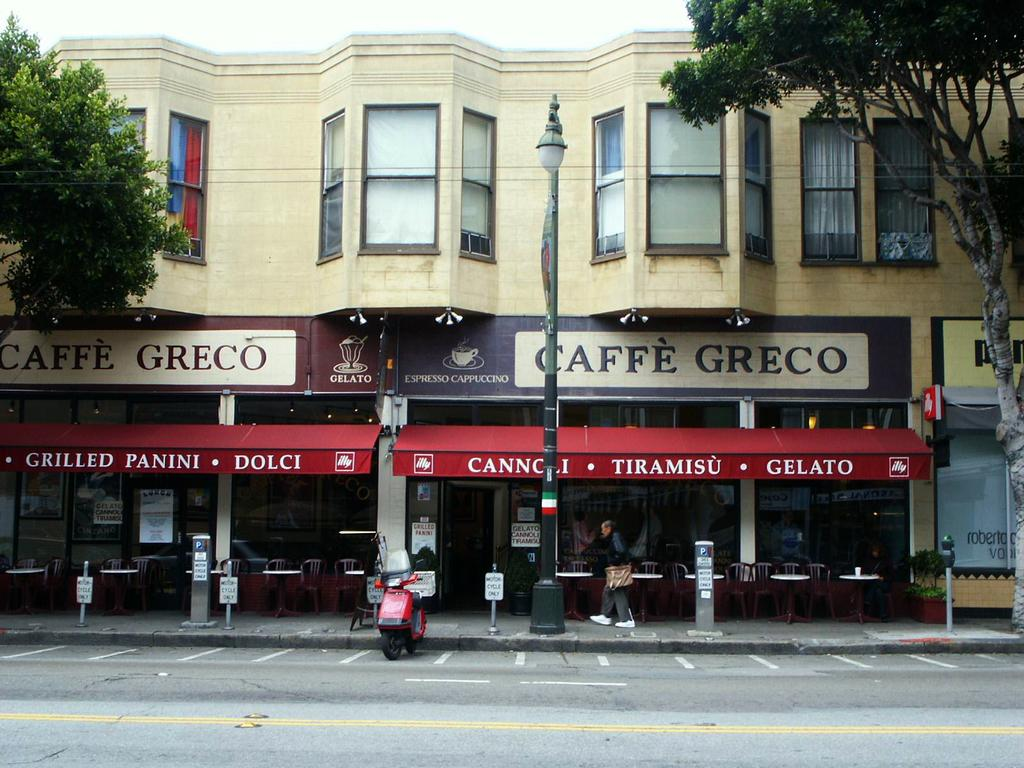What is the main subject of the image? There is a person standing in front of a building. What is in front of the building? There is a road in front of the building. What is in the middle of the road? A bike is present in the middle of the road. What type of vegetation is on either side of the road? There are trees on either side of the road. What is visible above the scene? The sky is visible above the scene. How does the person change the color of the building in the image? The person does not change the color of the building in the image; they are simply standing in front of it. 